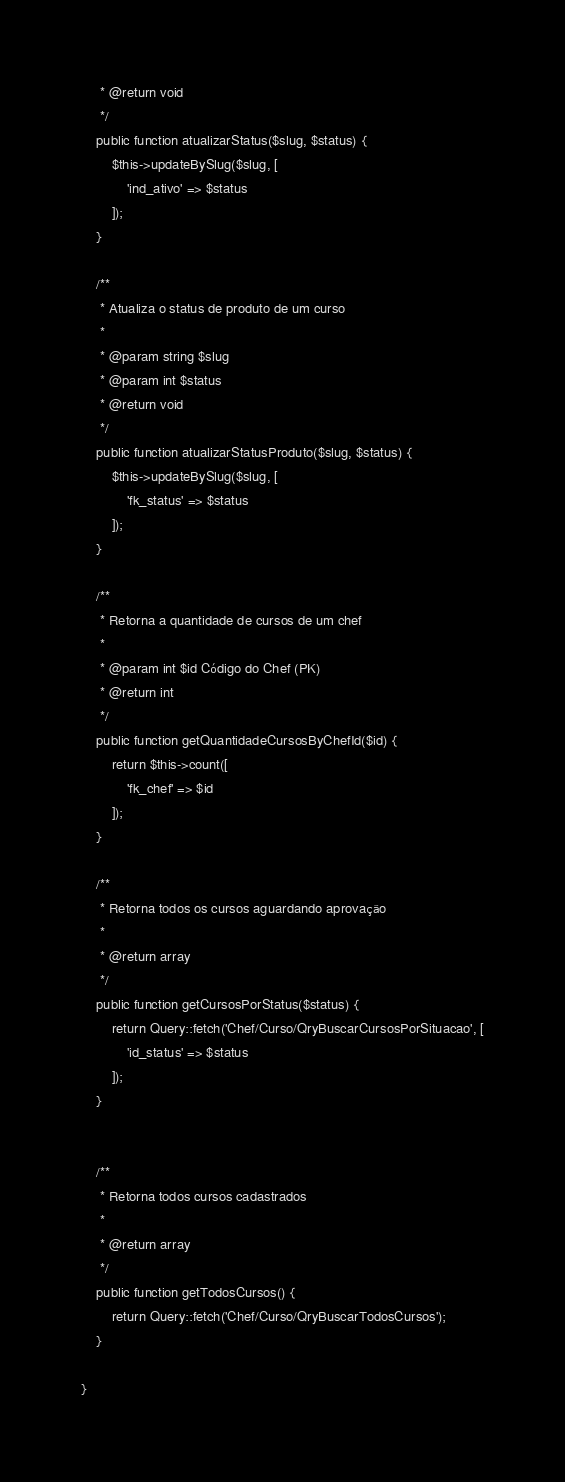Convert code to text. <code><loc_0><loc_0><loc_500><loc_500><_PHP_>     * @return void
     */
    public function atualizarStatus($slug, $status) {
        $this->updateBySlug($slug, [
            'ind_ativo' => $status
        ]);
    }

    /**
     * Atualiza o status de produto de um curso
     *
     * @param string $slug
     * @param int $status
     * @return void
     */
    public function atualizarStatusProduto($slug, $status) {
        $this->updateBySlug($slug, [
            'fk_status' => $status
        ]);
    }

    /**
     * Retorna a quantidade de cursos de um chef
     *
     * @param int $id Código do Chef (PK)
     * @return int
     */
    public function getQuantidadeCursosByChefId($id) {
        return $this->count([
            'fk_chef' => $id
        ]);
    }

    /**
     * Retorna todos os cursos aguardando aprovação
     *
     * @return array
     */
    public function getCursosPorStatus($status) {
        return Query::fetch('Chef/Curso/QryBuscarCursosPorSituacao', [
            'id_status' => $status
        ]);
    }


    /**
     * Retorna todos cursos cadastrados
     *
     * @return array
     */
    public function getTodosCursos() {
        return Query::fetch('Chef/Curso/QryBuscarTodosCursos');
    }

}</code> 